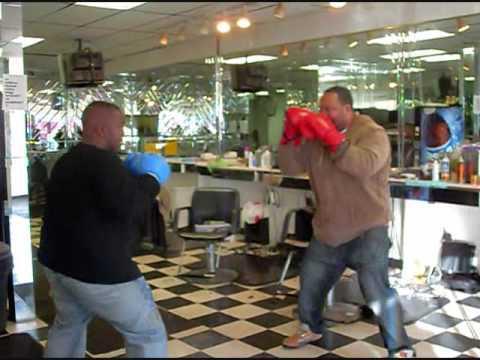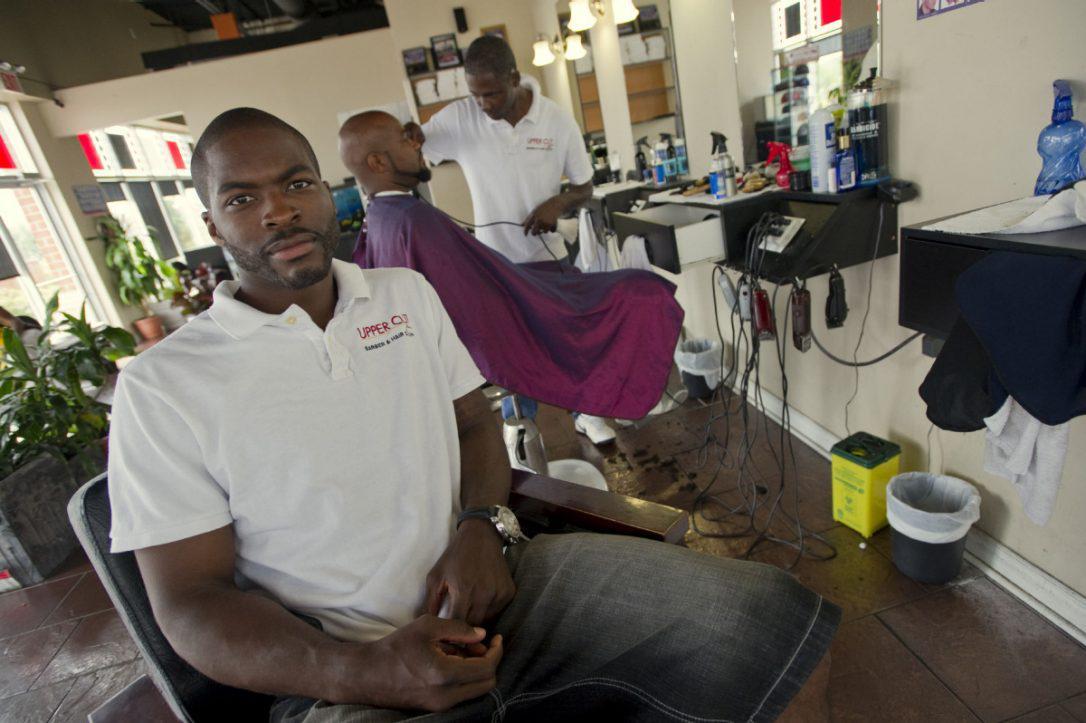The first image is the image on the left, the second image is the image on the right. Evaluate the accuracy of this statement regarding the images: "THere are exactly two people in the image on the left.". Is it true? Answer yes or no. Yes. 